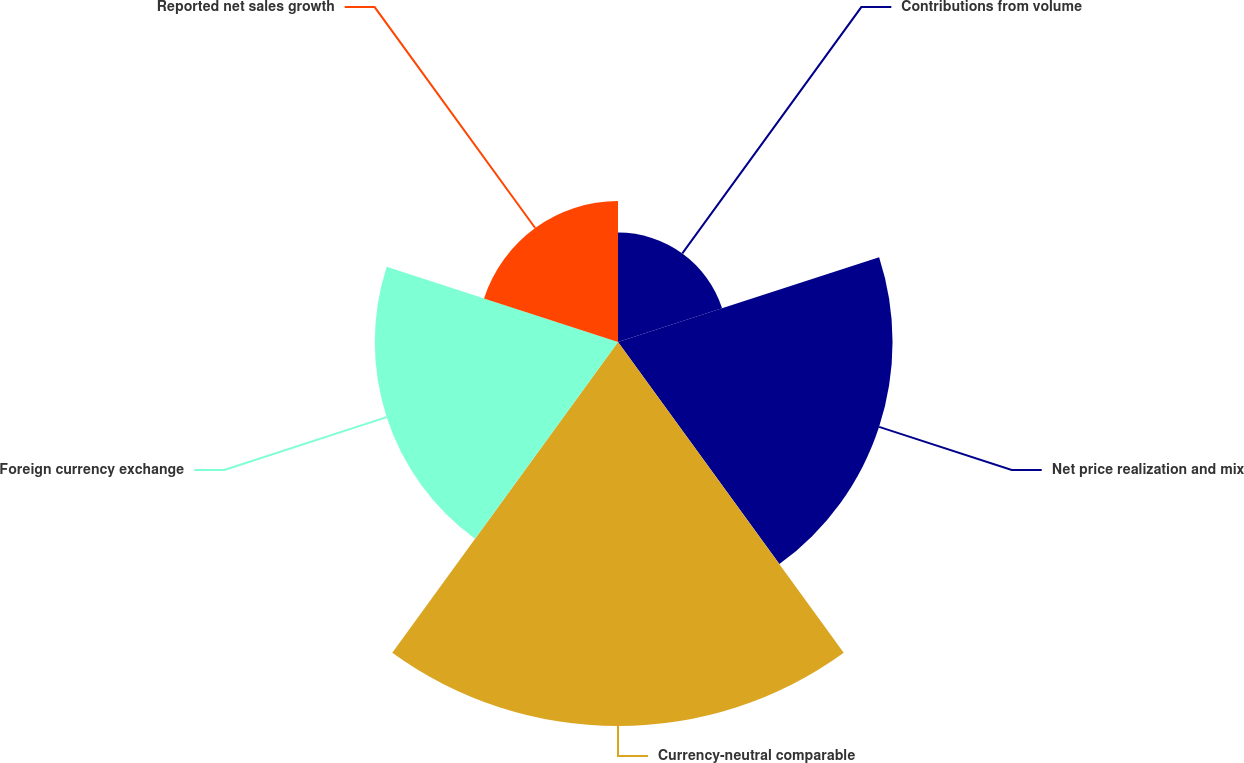Convert chart. <chart><loc_0><loc_0><loc_500><loc_500><pie_chart><fcel>Contributions from volume<fcel>Net price realization and mix<fcel>Currency-neutral comparable<fcel>Foreign currency exchange<fcel>Reported net sales growth<nl><fcel>9.5%<fcel>23.83%<fcel>33.33%<fcel>21.11%<fcel>12.23%<nl></chart> 